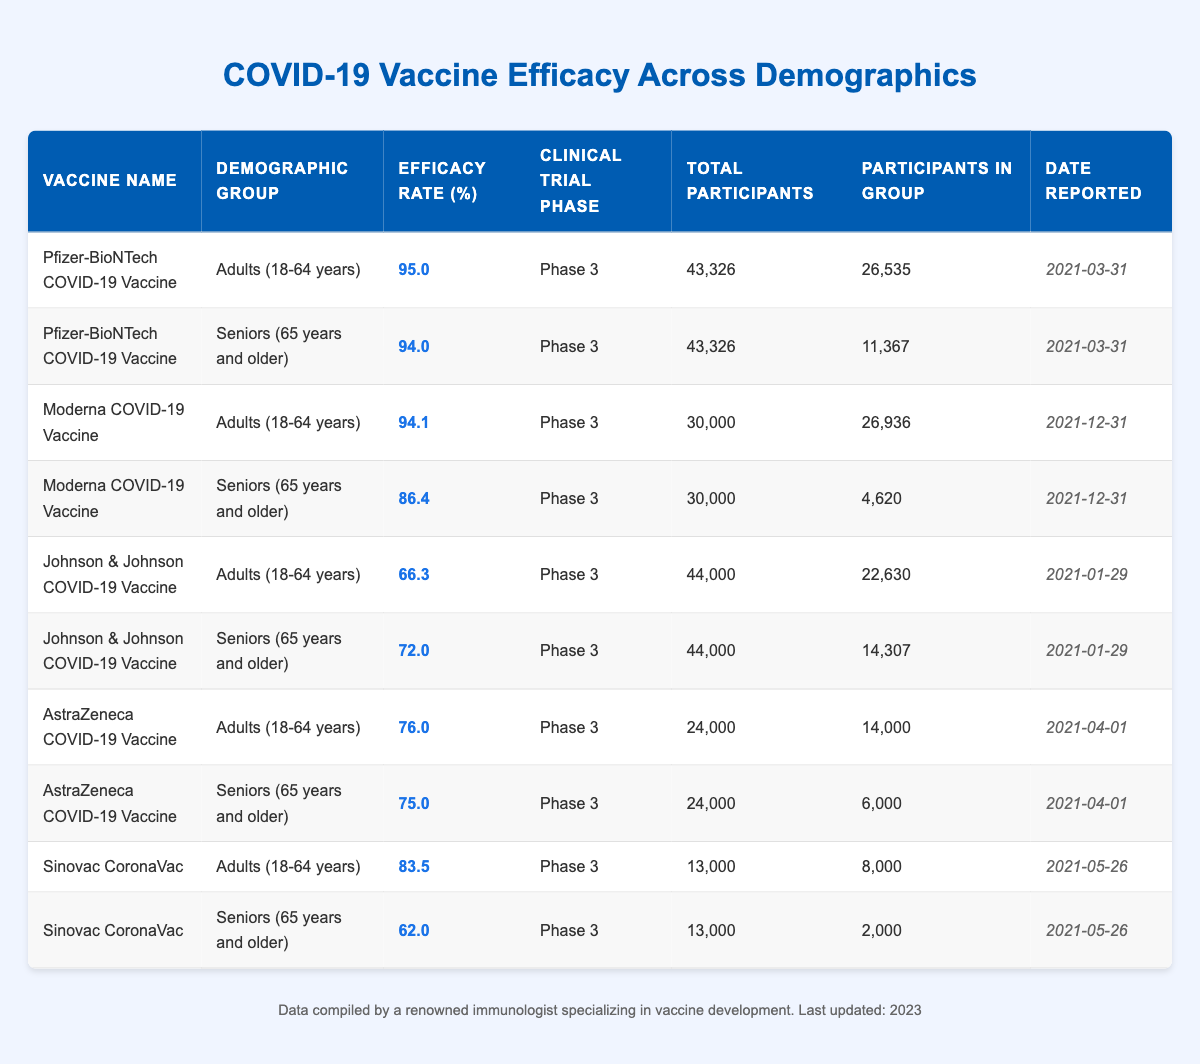What is the efficacy rate of the Pfizer-BioNTech COVID-19 Vaccine for adults aged 18-64 years? The table indicates that the efficacy rate of the Pfizer-BioNTech COVID-19 Vaccine for the demographic group of adults aged 18-64 years is 95%.
Answer: 95% What is the efficacy rate of the Moderna vaccine for seniors aged 65 years and older? According to the table, the efficacy rate of the Moderna COVID-19 Vaccine for seniors (65 years and older) is 86.4%.
Answer: 86.4% Which vaccine has the lowest efficacy rate among adults aged 18-64 years? By comparing the efficacy rates for adults in the table, the Johnson & Johnson COVID-19 Vaccine has the lowest efficacy rate at 66.3%.
Answer: 66.3% What is the total number of participants in the clinical trials for the Johnson & Johnson vaccine? The table shows that the total number of participants in the clinical trials for the Johnson & Johnson COVID-19 Vaccine is 44,000.
Answer: 44,000 When was the efficacy data for the AstraZeneca COVID-19 Vaccine reported? The table states that the efficacy data for the AstraZeneca COVID-19 Vaccine was reported on April 1, 2021.
Answer: April 1, 2021 Is the efficacy rate of Sinovac CoronaVac for seniors lower than that for adults? Yes, the efficacy rate for seniors (62%) is lower than the efficacy rate for adults (83.5%) as shown in the table.
Answer: Yes What is the average efficacy rate of all vaccines for seniors aged 65 years and older? The efficacy rates for seniors are 94, 86.4, 72, 75, and 62. Summing these gives 389. Dividing by the number of vaccines, which is 5, gives an average of 77.8%.
Answer: 77.8% For which vaccine does the efficacy rate drop the most from adults (18-64 years) to seniors (65 years and older)? To find the largest drop, we need to calculate the difference between the efficacy rates for adults and seniors for each vaccine. The drop for Moderna is 94.1% - 86.4% = 7.7%, for Johnson & Johnson is 66.3% - 72% = -5.7% (increase), for AstraZeneca is 76% - 75% = 1%, and for Sinovac is 83.5% - 62% = 21.5%. Sinovac has the largest drop at 21.5%.
Answer: Sinovac CoronaVac What percentage of the total participants were seniors in the clinical trial of the Moderna COVID-19 Vaccine? The total number of participants for the Moderna vaccine is 30,000, and the participants in the seniors group is 4,620. To find the percentage, we calculate (4620 / 30000) * 100 = 15.4%.
Answer: 15.4% 